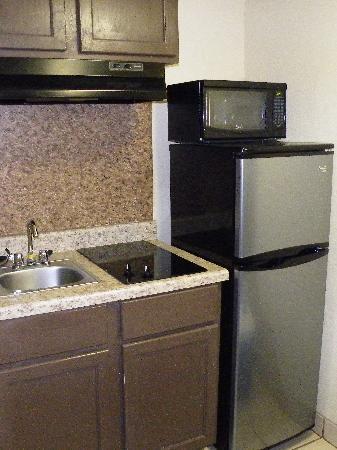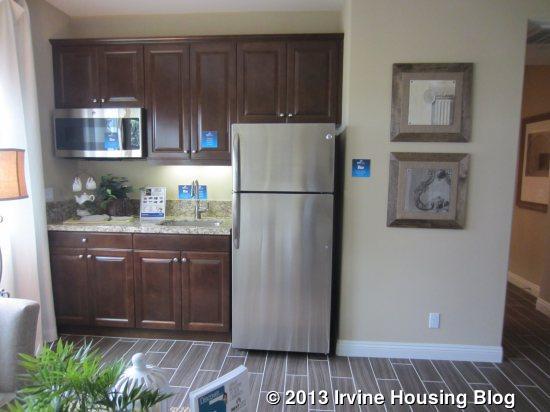The first image is the image on the left, the second image is the image on the right. For the images shown, is this caption "There is a refrigerator next to a counter containing a wash basin." true? Answer yes or no. Yes. The first image is the image on the left, the second image is the image on the right. For the images displayed, is the sentence "A mirror sits over the sink in the image on the right." factually correct? Answer yes or no. No. 